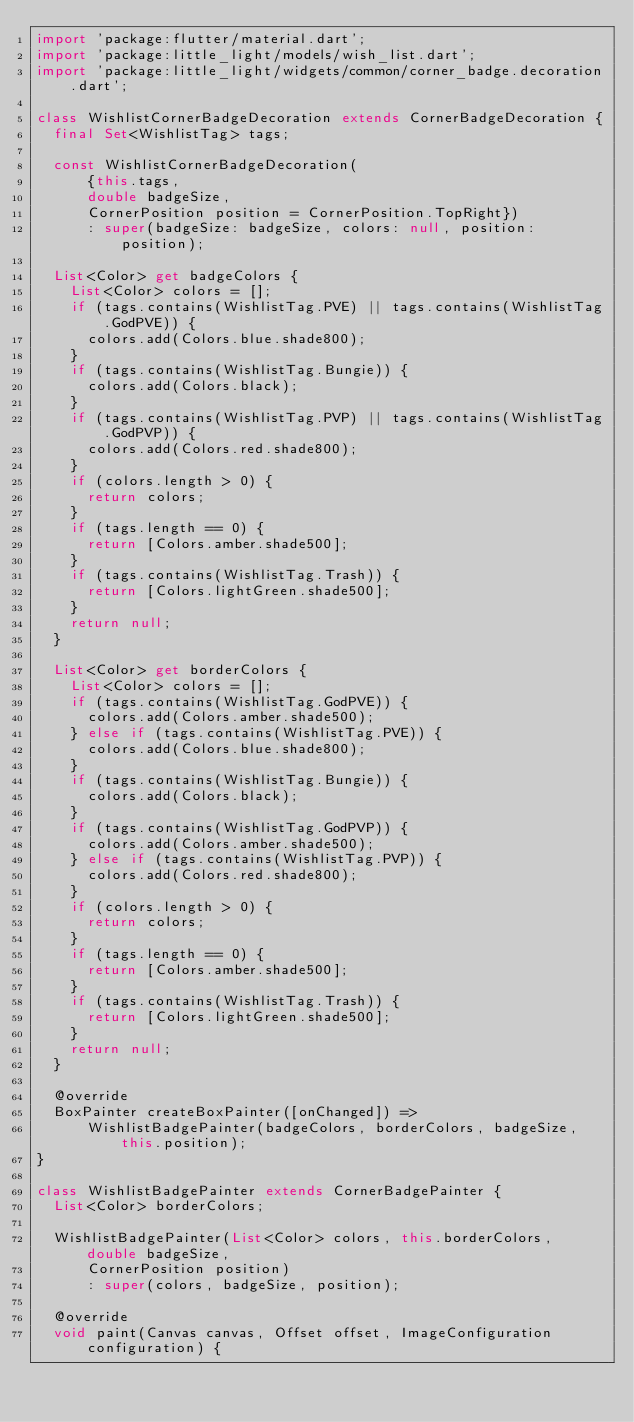<code> <loc_0><loc_0><loc_500><loc_500><_Dart_>import 'package:flutter/material.dart';
import 'package:little_light/models/wish_list.dart';
import 'package:little_light/widgets/common/corner_badge.decoration.dart';

class WishlistCornerBadgeDecoration extends CornerBadgeDecoration {
  final Set<WishlistTag> tags;

  const WishlistCornerBadgeDecoration(
      {this.tags,
      double badgeSize,
      CornerPosition position = CornerPosition.TopRight})
      : super(badgeSize: badgeSize, colors: null, position: position);

  List<Color> get badgeColors {
    List<Color> colors = [];
    if (tags.contains(WishlistTag.PVE) || tags.contains(WishlistTag.GodPVE)) {
      colors.add(Colors.blue.shade800);
    }
    if (tags.contains(WishlistTag.Bungie)) {
      colors.add(Colors.black);
    }
    if (tags.contains(WishlistTag.PVP) || tags.contains(WishlistTag.GodPVP)) {
      colors.add(Colors.red.shade800);
    }
    if (colors.length > 0) {
      return colors;
    }
    if (tags.length == 0) {
      return [Colors.amber.shade500];
    }
    if (tags.contains(WishlistTag.Trash)) {
      return [Colors.lightGreen.shade500];
    }
    return null;
  }

  List<Color> get borderColors {
    List<Color> colors = [];
    if (tags.contains(WishlistTag.GodPVE)) {
      colors.add(Colors.amber.shade500);
    } else if (tags.contains(WishlistTag.PVE)) {
      colors.add(Colors.blue.shade800);
    }
    if (tags.contains(WishlistTag.Bungie)) {
      colors.add(Colors.black);
    }
    if (tags.contains(WishlistTag.GodPVP)) {
      colors.add(Colors.amber.shade500);
    } else if (tags.contains(WishlistTag.PVP)) {
      colors.add(Colors.red.shade800);
    }
    if (colors.length > 0) {
      return colors;
    }
    if (tags.length == 0) {
      return [Colors.amber.shade500];
    }
    if (tags.contains(WishlistTag.Trash)) {
      return [Colors.lightGreen.shade500];
    }
    return null;
  }

  @override
  BoxPainter createBoxPainter([onChanged]) =>
      WishlistBadgePainter(badgeColors, borderColors, badgeSize, this.position);
}

class WishlistBadgePainter extends CornerBadgePainter {
  List<Color> borderColors;

  WishlistBadgePainter(List<Color> colors, this.borderColors, double badgeSize,
      CornerPosition position)
      : super(colors, badgeSize, position);

  @override
  void paint(Canvas canvas, Offset offset, ImageConfiguration configuration) {</code> 